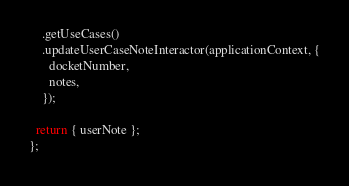Convert code to text. <code><loc_0><loc_0><loc_500><loc_500><_JavaScript_>    .getUseCases()
    .updateUserCaseNoteInteractor(applicationContext, {
      docketNumber,
      notes,
    });

  return { userNote };
};
</code> 